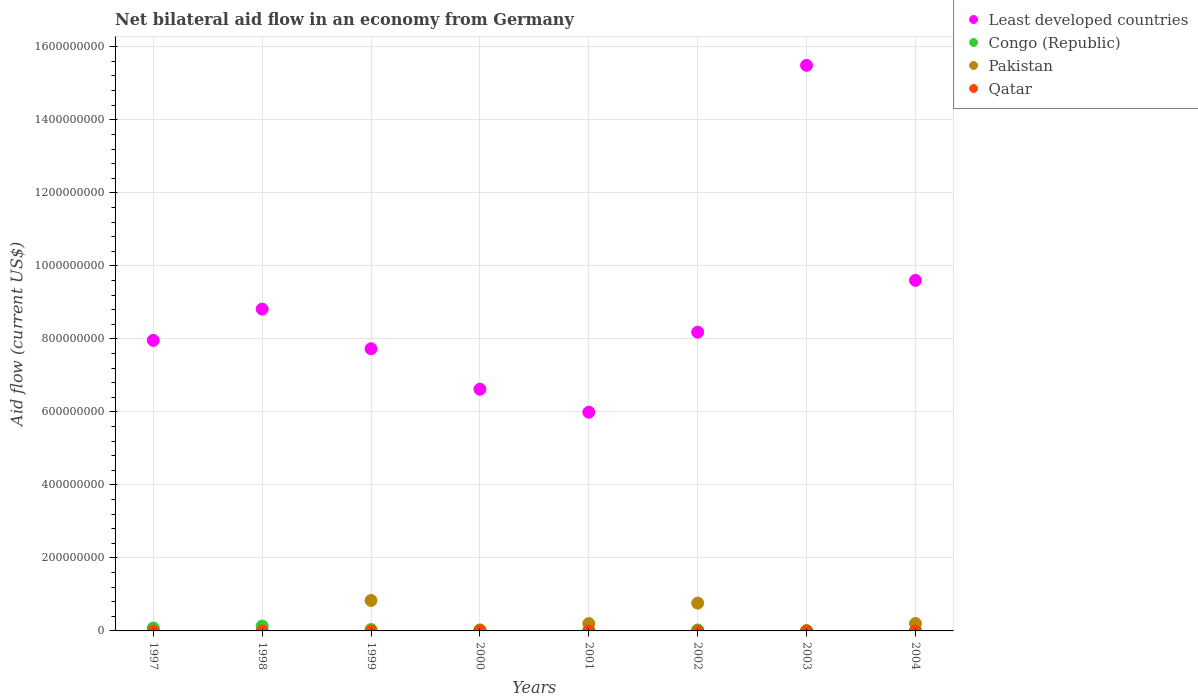How many different coloured dotlines are there?
Ensure brevity in your answer.  4. Across all years, what is the maximum net bilateral aid flow in Least developed countries?
Your answer should be very brief. 1.55e+09. Across all years, what is the minimum net bilateral aid flow in Congo (Republic)?
Offer a terse response. 5.20e+05. In which year was the net bilateral aid flow in Congo (Republic) maximum?
Keep it short and to the point. 1998. What is the total net bilateral aid flow in Congo (Republic) in the graph?
Ensure brevity in your answer.  3.32e+07. What is the difference between the net bilateral aid flow in Congo (Republic) in 2001 and that in 2003?
Ensure brevity in your answer.  8.10e+05. What is the difference between the net bilateral aid flow in Qatar in 2004 and the net bilateral aid flow in Least developed countries in 1997?
Your answer should be very brief. -7.96e+08. What is the average net bilateral aid flow in Qatar per year?
Your response must be concise. 9.12e+04. In the year 1998, what is the difference between the net bilateral aid flow in Congo (Republic) and net bilateral aid flow in Qatar?
Your answer should be very brief. 1.33e+07. What is the ratio of the net bilateral aid flow in Least developed countries in 1997 to that in 2002?
Offer a very short reply. 0.97. Is the net bilateral aid flow in Congo (Republic) in 2002 less than that in 2004?
Make the answer very short. No. What is the difference between the highest and the second highest net bilateral aid flow in Least developed countries?
Provide a short and direct response. 5.89e+08. What is the difference between the highest and the lowest net bilateral aid flow in Pakistan?
Provide a succinct answer. 8.34e+07. In how many years, is the net bilateral aid flow in Qatar greater than the average net bilateral aid flow in Qatar taken over all years?
Provide a succinct answer. 3. Is the sum of the net bilateral aid flow in Congo (Republic) in 1997 and 2000 greater than the maximum net bilateral aid flow in Pakistan across all years?
Provide a short and direct response. No. Is it the case that in every year, the sum of the net bilateral aid flow in Congo (Republic) and net bilateral aid flow in Pakistan  is greater than the net bilateral aid flow in Qatar?
Offer a terse response. Yes. Does the net bilateral aid flow in Congo (Republic) monotonically increase over the years?
Keep it short and to the point. No. Is the net bilateral aid flow in Congo (Republic) strictly less than the net bilateral aid flow in Qatar over the years?
Your answer should be compact. No. How many dotlines are there?
Give a very brief answer. 4. How many years are there in the graph?
Offer a very short reply. 8. What is the difference between two consecutive major ticks on the Y-axis?
Offer a very short reply. 2.00e+08. Does the graph contain grids?
Keep it short and to the point. Yes. How are the legend labels stacked?
Keep it short and to the point. Vertical. What is the title of the graph?
Your answer should be compact. Net bilateral aid flow in an economy from Germany. What is the label or title of the Y-axis?
Your answer should be compact. Aid flow (current US$). What is the Aid flow (current US$) of Least developed countries in 1997?
Make the answer very short. 7.96e+08. What is the Aid flow (current US$) of Congo (Republic) in 1997?
Ensure brevity in your answer.  7.95e+06. What is the Aid flow (current US$) in Least developed countries in 1998?
Keep it short and to the point. 8.81e+08. What is the Aid flow (current US$) of Congo (Republic) in 1998?
Keep it short and to the point. 1.35e+07. What is the Aid flow (current US$) of Pakistan in 1998?
Your answer should be very brief. 0. What is the Aid flow (current US$) of Qatar in 1998?
Your response must be concise. 1.40e+05. What is the Aid flow (current US$) of Least developed countries in 1999?
Your response must be concise. 7.73e+08. What is the Aid flow (current US$) of Congo (Republic) in 1999?
Provide a short and direct response. 3.76e+06. What is the Aid flow (current US$) in Pakistan in 1999?
Provide a succinct answer. 8.34e+07. What is the Aid flow (current US$) in Least developed countries in 2000?
Make the answer very short. 6.62e+08. What is the Aid flow (current US$) of Congo (Republic) in 2000?
Ensure brevity in your answer.  2.34e+06. What is the Aid flow (current US$) in Pakistan in 2000?
Your answer should be compact. 2.43e+06. What is the Aid flow (current US$) in Least developed countries in 2001?
Keep it short and to the point. 5.99e+08. What is the Aid flow (current US$) in Congo (Republic) in 2001?
Keep it short and to the point. 1.66e+06. What is the Aid flow (current US$) of Pakistan in 2001?
Your answer should be very brief. 2.01e+07. What is the Aid flow (current US$) of Least developed countries in 2002?
Your response must be concise. 8.18e+08. What is the Aid flow (current US$) of Congo (Republic) in 2002?
Offer a very short reply. 2.60e+06. What is the Aid flow (current US$) in Pakistan in 2002?
Keep it short and to the point. 7.62e+07. What is the Aid flow (current US$) in Qatar in 2002?
Provide a succinct answer. 8.00e+04. What is the Aid flow (current US$) of Least developed countries in 2003?
Make the answer very short. 1.55e+09. What is the Aid flow (current US$) in Congo (Republic) in 2003?
Your answer should be very brief. 8.50e+05. What is the Aid flow (current US$) of Least developed countries in 2004?
Provide a succinct answer. 9.60e+08. What is the Aid flow (current US$) of Congo (Republic) in 2004?
Provide a short and direct response. 5.20e+05. What is the Aid flow (current US$) of Pakistan in 2004?
Your answer should be compact. 2.04e+07. Across all years, what is the maximum Aid flow (current US$) in Least developed countries?
Offer a very short reply. 1.55e+09. Across all years, what is the maximum Aid flow (current US$) of Congo (Republic)?
Your answer should be compact. 1.35e+07. Across all years, what is the maximum Aid flow (current US$) of Pakistan?
Provide a succinct answer. 8.34e+07. Across all years, what is the minimum Aid flow (current US$) of Least developed countries?
Provide a short and direct response. 5.99e+08. Across all years, what is the minimum Aid flow (current US$) of Congo (Republic)?
Your answer should be compact. 5.20e+05. Across all years, what is the minimum Aid flow (current US$) in Pakistan?
Give a very brief answer. 0. Across all years, what is the minimum Aid flow (current US$) of Qatar?
Give a very brief answer. 5.00e+04. What is the total Aid flow (current US$) in Least developed countries in the graph?
Keep it short and to the point. 7.04e+09. What is the total Aid flow (current US$) in Congo (Republic) in the graph?
Your answer should be very brief. 3.32e+07. What is the total Aid flow (current US$) in Pakistan in the graph?
Your answer should be compact. 2.03e+08. What is the total Aid flow (current US$) in Qatar in the graph?
Your answer should be very brief. 7.30e+05. What is the difference between the Aid flow (current US$) in Least developed countries in 1997 and that in 1998?
Provide a short and direct response. -8.56e+07. What is the difference between the Aid flow (current US$) of Congo (Republic) in 1997 and that in 1998?
Give a very brief answer. -5.52e+06. What is the difference between the Aid flow (current US$) of Least developed countries in 1997 and that in 1999?
Your answer should be compact. 2.29e+07. What is the difference between the Aid flow (current US$) of Congo (Republic) in 1997 and that in 1999?
Give a very brief answer. 4.19e+06. What is the difference between the Aid flow (current US$) of Qatar in 1997 and that in 1999?
Offer a terse response. -6.00e+04. What is the difference between the Aid flow (current US$) of Least developed countries in 1997 and that in 2000?
Keep it short and to the point. 1.34e+08. What is the difference between the Aid flow (current US$) of Congo (Republic) in 1997 and that in 2000?
Ensure brevity in your answer.  5.61e+06. What is the difference between the Aid flow (current US$) in Least developed countries in 1997 and that in 2001?
Keep it short and to the point. 1.97e+08. What is the difference between the Aid flow (current US$) of Congo (Republic) in 1997 and that in 2001?
Your response must be concise. 6.29e+06. What is the difference between the Aid flow (current US$) of Qatar in 1997 and that in 2001?
Give a very brief answer. -3.00e+04. What is the difference between the Aid flow (current US$) in Least developed countries in 1997 and that in 2002?
Offer a very short reply. -2.25e+07. What is the difference between the Aid flow (current US$) in Congo (Republic) in 1997 and that in 2002?
Your answer should be compact. 5.35e+06. What is the difference between the Aid flow (current US$) of Qatar in 1997 and that in 2002?
Provide a succinct answer. -3.00e+04. What is the difference between the Aid flow (current US$) of Least developed countries in 1997 and that in 2003?
Your answer should be compact. -7.53e+08. What is the difference between the Aid flow (current US$) of Congo (Republic) in 1997 and that in 2003?
Offer a terse response. 7.10e+06. What is the difference between the Aid flow (current US$) in Qatar in 1997 and that in 2003?
Provide a succinct answer. -2.00e+04. What is the difference between the Aid flow (current US$) of Least developed countries in 1997 and that in 2004?
Keep it short and to the point. -1.64e+08. What is the difference between the Aid flow (current US$) of Congo (Republic) in 1997 and that in 2004?
Provide a short and direct response. 7.43e+06. What is the difference between the Aid flow (current US$) of Least developed countries in 1998 and that in 1999?
Your answer should be very brief. 1.09e+08. What is the difference between the Aid flow (current US$) in Congo (Republic) in 1998 and that in 1999?
Ensure brevity in your answer.  9.71e+06. What is the difference between the Aid flow (current US$) in Qatar in 1998 and that in 1999?
Offer a very short reply. 3.00e+04. What is the difference between the Aid flow (current US$) in Least developed countries in 1998 and that in 2000?
Provide a succinct answer. 2.19e+08. What is the difference between the Aid flow (current US$) of Congo (Republic) in 1998 and that in 2000?
Offer a terse response. 1.11e+07. What is the difference between the Aid flow (current US$) in Qatar in 1998 and that in 2000?
Offer a very short reply. 10000. What is the difference between the Aid flow (current US$) of Least developed countries in 1998 and that in 2001?
Provide a short and direct response. 2.82e+08. What is the difference between the Aid flow (current US$) in Congo (Republic) in 1998 and that in 2001?
Your answer should be compact. 1.18e+07. What is the difference between the Aid flow (current US$) in Least developed countries in 1998 and that in 2002?
Ensure brevity in your answer.  6.31e+07. What is the difference between the Aid flow (current US$) of Congo (Republic) in 1998 and that in 2002?
Provide a short and direct response. 1.09e+07. What is the difference between the Aid flow (current US$) in Qatar in 1998 and that in 2002?
Keep it short and to the point. 6.00e+04. What is the difference between the Aid flow (current US$) in Least developed countries in 1998 and that in 2003?
Give a very brief answer. -6.68e+08. What is the difference between the Aid flow (current US$) in Congo (Republic) in 1998 and that in 2003?
Your answer should be very brief. 1.26e+07. What is the difference between the Aid flow (current US$) in Least developed countries in 1998 and that in 2004?
Keep it short and to the point. -7.87e+07. What is the difference between the Aid flow (current US$) in Congo (Republic) in 1998 and that in 2004?
Your response must be concise. 1.30e+07. What is the difference between the Aid flow (current US$) of Qatar in 1998 and that in 2004?
Ensure brevity in your answer.  7.00e+04. What is the difference between the Aid flow (current US$) of Least developed countries in 1999 and that in 2000?
Your response must be concise. 1.11e+08. What is the difference between the Aid flow (current US$) in Congo (Republic) in 1999 and that in 2000?
Give a very brief answer. 1.42e+06. What is the difference between the Aid flow (current US$) of Pakistan in 1999 and that in 2000?
Ensure brevity in your answer.  8.10e+07. What is the difference between the Aid flow (current US$) of Qatar in 1999 and that in 2000?
Offer a terse response. -2.00e+04. What is the difference between the Aid flow (current US$) in Least developed countries in 1999 and that in 2001?
Offer a terse response. 1.74e+08. What is the difference between the Aid flow (current US$) in Congo (Republic) in 1999 and that in 2001?
Make the answer very short. 2.10e+06. What is the difference between the Aid flow (current US$) in Pakistan in 1999 and that in 2001?
Provide a short and direct response. 6.33e+07. What is the difference between the Aid flow (current US$) of Least developed countries in 1999 and that in 2002?
Give a very brief answer. -4.54e+07. What is the difference between the Aid flow (current US$) of Congo (Republic) in 1999 and that in 2002?
Your answer should be very brief. 1.16e+06. What is the difference between the Aid flow (current US$) in Pakistan in 1999 and that in 2002?
Provide a short and direct response. 7.25e+06. What is the difference between the Aid flow (current US$) of Least developed countries in 1999 and that in 2003?
Provide a short and direct response. -7.76e+08. What is the difference between the Aid flow (current US$) in Congo (Republic) in 1999 and that in 2003?
Ensure brevity in your answer.  2.91e+06. What is the difference between the Aid flow (current US$) of Qatar in 1999 and that in 2003?
Provide a succinct answer. 4.00e+04. What is the difference between the Aid flow (current US$) of Least developed countries in 1999 and that in 2004?
Your answer should be compact. -1.87e+08. What is the difference between the Aid flow (current US$) of Congo (Republic) in 1999 and that in 2004?
Provide a succinct answer. 3.24e+06. What is the difference between the Aid flow (current US$) in Pakistan in 1999 and that in 2004?
Your answer should be compact. 6.30e+07. What is the difference between the Aid flow (current US$) in Qatar in 1999 and that in 2004?
Give a very brief answer. 4.00e+04. What is the difference between the Aid flow (current US$) in Least developed countries in 2000 and that in 2001?
Provide a short and direct response. 6.29e+07. What is the difference between the Aid flow (current US$) of Congo (Republic) in 2000 and that in 2001?
Ensure brevity in your answer.  6.80e+05. What is the difference between the Aid flow (current US$) in Pakistan in 2000 and that in 2001?
Your answer should be very brief. -1.77e+07. What is the difference between the Aid flow (current US$) of Least developed countries in 2000 and that in 2002?
Your answer should be very brief. -1.56e+08. What is the difference between the Aid flow (current US$) of Pakistan in 2000 and that in 2002?
Provide a succinct answer. -7.38e+07. What is the difference between the Aid flow (current US$) of Least developed countries in 2000 and that in 2003?
Provide a short and direct response. -8.87e+08. What is the difference between the Aid flow (current US$) of Congo (Republic) in 2000 and that in 2003?
Offer a terse response. 1.49e+06. What is the difference between the Aid flow (current US$) in Qatar in 2000 and that in 2003?
Ensure brevity in your answer.  6.00e+04. What is the difference between the Aid flow (current US$) in Least developed countries in 2000 and that in 2004?
Make the answer very short. -2.98e+08. What is the difference between the Aid flow (current US$) of Congo (Republic) in 2000 and that in 2004?
Your response must be concise. 1.82e+06. What is the difference between the Aid flow (current US$) of Pakistan in 2000 and that in 2004?
Your answer should be compact. -1.80e+07. What is the difference between the Aid flow (current US$) in Qatar in 2000 and that in 2004?
Keep it short and to the point. 6.00e+04. What is the difference between the Aid flow (current US$) in Least developed countries in 2001 and that in 2002?
Offer a terse response. -2.19e+08. What is the difference between the Aid flow (current US$) in Congo (Republic) in 2001 and that in 2002?
Make the answer very short. -9.40e+05. What is the difference between the Aid flow (current US$) of Pakistan in 2001 and that in 2002?
Offer a very short reply. -5.61e+07. What is the difference between the Aid flow (current US$) in Least developed countries in 2001 and that in 2003?
Your response must be concise. -9.50e+08. What is the difference between the Aid flow (current US$) of Congo (Republic) in 2001 and that in 2003?
Ensure brevity in your answer.  8.10e+05. What is the difference between the Aid flow (current US$) of Least developed countries in 2001 and that in 2004?
Keep it short and to the point. -3.61e+08. What is the difference between the Aid flow (current US$) of Congo (Republic) in 2001 and that in 2004?
Give a very brief answer. 1.14e+06. What is the difference between the Aid flow (current US$) in Pakistan in 2001 and that in 2004?
Provide a succinct answer. -3.10e+05. What is the difference between the Aid flow (current US$) of Least developed countries in 2002 and that in 2003?
Your answer should be compact. -7.31e+08. What is the difference between the Aid flow (current US$) of Congo (Republic) in 2002 and that in 2003?
Give a very brief answer. 1.75e+06. What is the difference between the Aid flow (current US$) in Least developed countries in 2002 and that in 2004?
Keep it short and to the point. -1.42e+08. What is the difference between the Aid flow (current US$) in Congo (Republic) in 2002 and that in 2004?
Provide a succinct answer. 2.08e+06. What is the difference between the Aid flow (current US$) in Pakistan in 2002 and that in 2004?
Offer a very short reply. 5.58e+07. What is the difference between the Aid flow (current US$) of Qatar in 2002 and that in 2004?
Offer a terse response. 10000. What is the difference between the Aid flow (current US$) in Least developed countries in 2003 and that in 2004?
Your answer should be very brief. 5.89e+08. What is the difference between the Aid flow (current US$) of Least developed countries in 1997 and the Aid flow (current US$) of Congo (Republic) in 1998?
Your answer should be compact. 7.82e+08. What is the difference between the Aid flow (current US$) of Least developed countries in 1997 and the Aid flow (current US$) of Qatar in 1998?
Your answer should be compact. 7.96e+08. What is the difference between the Aid flow (current US$) in Congo (Republic) in 1997 and the Aid flow (current US$) in Qatar in 1998?
Make the answer very short. 7.81e+06. What is the difference between the Aid flow (current US$) in Least developed countries in 1997 and the Aid flow (current US$) in Congo (Republic) in 1999?
Provide a short and direct response. 7.92e+08. What is the difference between the Aid flow (current US$) in Least developed countries in 1997 and the Aid flow (current US$) in Pakistan in 1999?
Your answer should be very brief. 7.12e+08. What is the difference between the Aid flow (current US$) in Least developed countries in 1997 and the Aid flow (current US$) in Qatar in 1999?
Offer a very short reply. 7.96e+08. What is the difference between the Aid flow (current US$) of Congo (Republic) in 1997 and the Aid flow (current US$) of Pakistan in 1999?
Offer a very short reply. -7.55e+07. What is the difference between the Aid flow (current US$) of Congo (Republic) in 1997 and the Aid flow (current US$) of Qatar in 1999?
Your response must be concise. 7.84e+06. What is the difference between the Aid flow (current US$) in Least developed countries in 1997 and the Aid flow (current US$) in Congo (Republic) in 2000?
Offer a terse response. 7.94e+08. What is the difference between the Aid flow (current US$) in Least developed countries in 1997 and the Aid flow (current US$) in Pakistan in 2000?
Offer a terse response. 7.93e+08. What is the difference between the Aid flow (current US$) in Least developed countries in 1997 and the Aid flow (current US$) in Qatar in 2000?
Ensure brevity in your answer.  7.96e+08. What is the difference between the Aid flow (current US$) in Congo (Republic) in 1997 and the Aid flow (current US$) in Pakistan in 2000?
Provide a short and direct response. 5.52e+06. What is the difference between the Aid flow (current US$) in Congo (Republic) in 1997 and the Aid flow (current US$) in Qatar in 2000?
Provide a succinct answer. 7.82e+06. What is the difference between the Aid flow (current US$) of Least developed countries in 1997 and the Aid flow (current US$) of Congo (Republic) in 2001?
Offer a terse response. 7.94e+08. What is the difference between the Aid flow (current US$) of Least developed countries in 1997 and the Aid flow (current US$) of Pakistan in 2001?
Make the answer very short. 7.76e+08. What is the difference between the Aid flow (current US$) of Least developed countries in 1997 and the Aid flow (current US$) of Qatar in 2001?
Offer a terse response. 7.96e+08. What is the difference between the Aid flow (current US$) in Congo (Republic) in 1997 and the Aid flow (current US$) in Pakistan in 2001?
Make the answer very short. -1.22e+07. What is the difference between the Aid flow (current US$) in Congo (Republic) in 1997 and the Aid flow (current US$) in Qatar in 2001?
Your answer should be very brief. 7.87e+06. What is the difference between the Aid flow (current US$) in Least developed countries in 1997 and the Aid flow (current US$) in Congo (Republic) in 2002?
Keep it short and to the point. 7.93e+08. What is the difference between the Aid flow (current US$) in Least developed countries in 1997 and the Aid flow (current US$) in Pakistan in 2002?
Offer a very short reply. 7.20e+08. What is the difference between the Aid flow (current US$) of Least developed countries in 1997 and the Aid flow (current US$) of Qatar in 2002?
Your answer should be compact. 7.96e+08. What is the difference between the Aid flow (current US$) of Congo (Republic) in 1997 and the Aid flow (current US$) of Pakistan in 2002?
Your answer should be compact. -6.82e+07. What is the difference between the Aid flow (current US$) of Congo (Republic) in 1997 and the Aid flow (current US$) of Qatar in 2002?
Provide a short and direct response. 7.87e+06. What is the difference between the Aid flow (current US$) in Least developed countries in 1997 and the Aid flow (current US$) in Congo (Republic) in 2003?
Offer a terse response. 7.95e+08. What is the difference between the Aid flow (current US$) of Least developed countries in 1997 and the Aid flow (current US$) of Qatar in 2003?
Offer a very short reply. 7.96e+08. What is the difference between the Aid flow (current US$) of Congo (Republic) in 1997 and the Aid flow (current US$) of Qatar in 2003?
Your answer should be compact. 7.88e+06. What is the difference between the Aid flow (current US$) in Least developed countries in 1997 and the Aid flow (current US$) in Congo (Republic) in 2004?
Keep it short and to the point. 7.95e+08. What is the difference between the Aid flow (current US$) of Least developed countries in 1997 and the Aid flow (current US$) of Pakistan in 2004?
Your answer should be very brief. 7.75e+08. What is the difference between the Aid flow (current US$) in Least developed countries in 1997 and the Aid flow (current US$) in Qatar in 2004?
Your response must be concise. 7.96e+08. What is the difference between the Aid flow (current US$) of Congo (Republic) in 1997 and the Aid flow (current US$) of Pakistan in 2004?
Provide a succinct answer. -1.25e+07. What is the difference between the Aid flow (current US$) in Congo (Republic) in 1997 and the Aid flow (current US$) in Qatar in 2004?
Keep it short and to the point. 7.88e+06. What is the difference between the Aid flow (current US$) of Least developed countries in 1998 and the Aid flow (current US$) of Congo (Republic) in 1999?
Ensure brevity in your answer.  8.78e+08. What is the difference between the Aid flow (current US$) of Least developed countries in 1998 and the Aid flow (current US$) of Pakistan in 1999?
Provide a short and direct response. 7.98e+08. What is the difference between the Aid flow (current US$) of Least developed countries in 1998 and the Aid flow (current US$) of Qatar in 1999?
Offer a terse response. 8.81e+08. What is the difference between the Aid flow (current US$) in Congo (Republic) in 1998 and the Aid flow (current US$) in Pakistan in 1999?
Keep it short and to the point. -7.00e+07. What is the difference between the Aid flow (current US$) of Congo (Republic) in 1998 and the Aid flow (current US$) of Qatar in 1999?
Offer a terse response. 1.34e+07. What is the difference between the Aid flow (current US$) of Least developed countries in 1998 and the Aid flow (current US$) of Congo (Republic) in 2000?
Your answer should be compact. 8.79e+08. What is the difference between the Aid flow (current US$) in Least developed countries in 1998 and the Aid flow (current US$) in Pakistan in 2000?
Give a very brief answer. 8.79e+08. What is the difference between the Aid flow (current US$) of Least developed countries in 1998 and the Aid flow (current US$) of Qatar in 2000?
Offer a terse response. 8.81e+08. What is the difference between the Aid flow (current US$) in Congo (Republic) in 1998 and the Aid flow (current US$) in Pakistan in 2000?
Give a very brief answer. 1.10e+07. What is the difference between the Aid flow (current US$) of Congo (Republic) in 1998 and the Aid flow (current US$) of Qatar in 2000?
Your answer should be compact. 1.33e+07. What is the difference between the Aid flow (current US$) in Least developed countries in 1998 and the Aid flow (current US$) in Congo (Republic) in 2001?
Keep it short and to the point. 8.80e+08. What is the difference between the Aid flow (current US$) of Least developed countries in 1998 and the Aid flow (current US$) of Pakistan in 2001?
Your answer should be compact. 8.61e+08. What is the difference between the Aid flow (current US$) in Least developed countries in 1998 and the Aid flow (current US$) in Qatar in 2001?
Offer a very short reply. 8.81e+08. What is the difference between the Aid flow (current US$) in Congo (Republic) in 1998 and the Aid flow (current US$) in Pakistan in 2001?
Provide a short and direct response. -6.63e+06. What is the difference between the Aid flow (current US$) in Congo (Republic) in 1998 and the Aid flow (current US$) in Qatar in 2001?
Make the answer very short. 1.34e+07. What is the difference between the Aid flow (current US$) in Least developed countries in 1998 and the Aid flow (current US$) in Congo (Republic) in 2002?
Your response must be concise. 8.79e+08. What is the difference between the Aid flow (current US$) of Least developed countries in 1998 and the Aid flow (current US$) of Pakistan in 2002?
Ensure brevity in your answer.  8.05e+08. What is the difference between the Aid flow (current US$) in Least developed countries in 1998 and the Aid flow (current US$) in Qatar in 2002?
Offer a terse response. 8.81e+08. What is the difference between the Aid flow (current US$) in Congo (Republic) in 1998 and the Aid flow (current US$) in Pakistan in 2002?
Your response must be concise. -6.27e+07. What is the difference between the Aid flow (current US$) in Congo (Republic) in 1998 and the Aid flow (current US$) in Qatar in 2002?
Provide a succinct answer. 1.34e+07. What is the difference between the Aid flow (current US$) in Least developed countries in 1998 and the Aid flow (current US$) in Congo (Republic) in 2003?
Provide a succinct answer. 8.81e+08. What is the difference between the Aid flow (current US$) in Least developed countries in 1998 and the Aid flow (current US$) in Qatar in 2003?
Your answer should be compact. 8.81e+08. What is the difference between the Aid flow (current US$) in Congo (Republic) in 1998 and the Aid flow (current US$) in Qatar in 2003?
Your answer should be very brief. 1.34e+07. What is the difference between the Aid flow (current US$) in Least developed countries in 1998 and the Aid flow (current US$) in Congo (Republic) in 2004?
Give a very brief answer. 8.81e+08. What is the difference between the Aid flow (current US$) in Least developed countries in 1998 and the Aid flow (current US$) in Pakistan in 2004?
Offer a terse response. 8.61e+08. What is the difference between the Aid flow (current US$) of Least developed countries in 1998 and the Aid flow (current US$) of Qatar in 2004?
Offer a terse response. 8.81e+08. What is the difference between the Aid flow (current US$) of Congo (Republic) in 1998 and the Aid flow (current US$) of Pakistan in 2004?
Offer a terse response. -6.94e+06. What is the difference between the Aid flow (current US$) in Congo (Republic) in 1998 and the Aid flow (current US$) in Qatar in 2004?
Offer a very short reply. 1.34e+07. What is the difference between the Aid flow (current US$) of Least developed countries in 1999 and the Aid flow (current US$) of Congo (Republic) in 2000?
Your response must be concise. 7.71e+08. What is the difference between the Aid flow (current US$) in Least developed countries in 1999 and the Aid flow (current US$) in Pakistan in 2000?
Your answer should be very brief. 7.70e+08. What is the difference between the Aid flow (current US$) in Least developed countries in 1999 and the Aid flow (current US$) in Qatar in 2000?
Give a very brief answer. 7.73e+08. What is the difference between the Aid flow (current US$) of Congo (Republic) in 1999 and the Aid flow (current US$) of Pakistan in 2000?
Give a very brief answer. 1.33e+06. What is the difference between the Aid flow (current US$) of Congo (Republic) in 1999 and the Aid flow (current US$) of Qatar in 2000?
Keep it short and to the point. 3.63e+06. What is the difference between the Aid flow (current US$) in Pakistan in 1999 and the Aid flow (current US$) in Qatar in 2000?
Provide a succinct answer. 8.33e+07. What is the difference between the Aid flow (current US$) in Least developed countries in 1999 and the Aid flow (current US$) in Congo (Republic) in 2001?
Offer a very short reply. 7.71e+08. What is the difference between the Aid flow (current US$) of Least developed countries in 1999 and the Aid flow (current US$) of Pakistan in 2001?
Your answer should be compact. 7.53e+08. What is the difference between the Aid flow (current US$) in Least developed countries in 1999 and the Aid flow (current US$) in Qatar in 2001?
Your answer should be very brief. 7.73e+08. What is the difference between the Aid flow (current US$) of Congo (Republic) in 1999 and the Aid flow (current US$) of Pakistan in 2001?
Make the answer very short. -1.63e+07. What is the difference between the Aid flow (current US$) in Congo (Republic) in 1999 and the Aid flow (current US$) in Qatar in 2001?
Offer a very short reply. 3.68e+06. What is the difference between the Aid flow (current US$) in Pakistan in 1999 and the Aid flow (current US$) in Qatar in 2001?
Provide a succinct answer. 8.34e+07. What is the difference between the Aid flow (current US$) in Least developed countries in 1999 and the Aid flow (current US$) in Congo (Republic) in 2002?
Provide a short and direct response. 7.70e+08. What is the difference between the Aid flow (current US$) in Least developed countries in 1999 and the Aid flow (current US$) in Pakistan in 2002?
Provide a short and direct response. 6.97e+08. What is the difference between the Aid flow (current US$) of Least developed countries in 1999 and the Aid flow (current US$) of Qatar in 2002?
Offer a terse response. 7.73e+08. What is the difference between the Aid flow (current US$) of Congo (Republic) in 1999 and the Aid flow (current US$) of Pakistan in 2002?
Your answer should be very brief. -7.24e+07. What is the difference between the Aid flow (current US$) of Congo (Republic) in 1999 and the Aid flow (current US$) of Qatar in 2002?
Provide a succinct answer. 3.68e+06. What is the difference between the Aid flow (current US$) in Pakistan in 1999 and the Aid flow (current US$) in Qatar in 2002?
Ensure brevity in your answer.  8.34e+07. What is the difference between the Aid flow (current US$) in Least developed countries in 1999 and the Aid flow (current US$) in Congo (Republic) in 2003?
Give a very brief answer. 7.72e+08. What is the difference between the Aid flow (current US$) of Least developed countries in 1999 and the Aid flow (current US$) of Qatar in 2003?
Your answer should be compact. 7.73e+08. What is the difference between the Aid flow (current US$) in Congo (Republic) in 1999 and the Aid flow (current US$) in Qatar in 2003?
Make the answer very short. 3.69e+06. What is the difference between the Aid flow (current US$) in Pakistan in 1999 and the Aid flow (current US$) in Qatar in 2003?
Make the answer very short. 8.34e+07. What is the difference between the Aid flow (current US$) of Least developed countries in 1999 and the Aid flow (current US$) of Congo (Republic) in 2004?
Provide a succinct answer. 7.72e+08. What is the difference between the Aid flow (current US$) of Least developed countries in 1999 and the Aid flow (current US$) of Pakistan in 2004?
Offer a terse response. 7.53e+08. What is the difference between the Aid flow (current US$) of Least developed countries in 1999 and the Aid flow (current US$) of Qatar in 2004?
Give a very brief answer. 7.73e+08. What is the difference between the Aid flow (current US$) of Congo (Republic) in 1999 and the Aid flow (current US$) of Pakistan in 2004?
Ensure brevity in your answer.  -1.66e+07. What is the difference between the Aid flow (current US$) in Congo (Republic) in 1999 and the Aid flow (current US$) in Qatar in 2004?
Provide a short and direct response. 3.69e+06. What is the difference between the Aid flow (current US$) in Pakistan in 1999 and the Aid flow (current US$) in Qatar in 2004?
Your answer should be very brief. 8.34e+07. What is the difference between the Aid flow (current US$) of Least developed countries in 2000 and the Aid flow (current US$) of Congo (Republic) in 2001?
Make the answer very short. 6.60e+08. What is the difference between the Aid flow (current US$) of Least developed countries in 2000 and the Aid flow (current US$) of Pakistan in 2001?
Your response must be concise. 6.42e+08. What is the difference between the Aid flow (current US$) of Least developed countries in 2000 and the Aid flow (current US$) of Qatar in 2001?
Your response must be concise. 6.62e+08. What is the difference between the Aid flow (current US$) in Congo (Republic) in 2000 and the Aid flow (current US$) in Pakistan in 2001?
Provide a succinct answer. -1.78e+07. What is the difference between the Aid flow (current US$) in Congo (Republic) in 2000 and the Aid flow (current US$) in Qatar in 2001?
Provide a succinct answer. 2.26e+06. What is the difference between the Aid flow (current US$) of Pakistan in 2000 and the Aid flow (current US$) of Qatar in 2001?
Your answer should be very brief. 2.35e+06. What is the difference between the Aid flow (current US$) in Least developed countries in 2000 and the Aid flow (current US$) in Congo (Republic) in 2002?
Provide a succinct answer. 6.59e+08. What is the difference between the Aid flow (current US$) of Least developed countries in 2000 and the Aid flow (current US$) of Pakistan in 2002?
Your answer should be very brief. 5.86e+08. What is the difference between the Aid flow (current US$) of Least developed countries in 2000 and the Aid flow (current US$) of Qatar in 2002?
Make the answer very short. 6.62e+08. What is the difference between the Aid flow (current US$) of Congo (Republic) in 2000 and the Aid flow (current US$) of Pakistan in 2002?
Keep it short and to the point. -7.38e+07. What is the difference between the Aid flow (current US$) of Congo (Republic) in 2000 and the Aid flow (current US$) of Qatar in 2002?
Make the answer very short. 2.26e+06. What is the difference between the Aid flow (current US$) of Pakistan in 2000 and the Aid flow (current US$) of Qatar in 2002?
Offer a very short reply. 2.35e+06. What is the difference between the Aid flow (current US$) of Least developed countries in 2000 and the Aid flow (current US$) of Congo (Republic) in 2003?
Offer a terse response. 6.61e+08. What is the difference between the Aid flow (current US$) in Least developed countries in 2000 and the Aid flow (current US$) in Qatar in 2003?
Provide a short and direct response. 6.62e+08. What is the difference between the Aid flow (current US$) of Congo (Republic) in 2000 and the Aid flow (current US$) of Qatar in 2003?
Keep it short and to the point. 2.27e+06. What is the difference between the Aid flow (current US$) in Pakistan in 2000 and the Aid flow (current US$) in Qatar in 2003?
Your answer should be compact. 2.36e+06. What is the difference between the Aid flow (current US$) in Least developed countries in 2000 and the Aid flow (current US$) in Congo (Republic) in 2004?
Your answer should be very brief. 6.61e+08. What is the difference between the Aid flow (current US$) in Least developed countries in 2000 and the Aid flow (current US$) in Pakistan in 2004?
Make the answer very short. 6.42e+08. What is the difference between the Aid flow (current US$) of Least developed countries in 2000 and the Aid flow (current US$) of Qatar in 2004?
Make the answer very short. 6.62e+08. What is the difference between the Aid flow (current US$) of Congo (Republic) in 2000 and the Aid flow (current US$) of Pakistan in 2004?
Offer a terse response. -1.81e+07. What is the difference between the Aid flow (current US$) of Congo (Republic) in 2000 and the Aid flow (current US$) of Qatar in 2004?
Keep it short and to the point. 2.27e+06. What is the difference between the Aid flow (current US$) in Pakistan in 2000 and the Aid flow (current US$) in Qatar in 2004?
Your answer should be compact. 2.36e+06. What is the difference between the Aid flow (current US$) in Least developed countries in 2001 and the Aid flow (current US$) in Congo (Republic) in 2002?
Provide a short and direct response. 5.96e+08. What is the difference between the Aid flow (current US$) in Least developed countries in 2001 and the Aid flow (current US$) in Pakistan in 2002?
Your answer should be compact. 5.23e+08. What is the difference between the Aid flow (current US$) in Least developed countries in 2001 and the Aid flow (current US$) in Qatar in 2002?
Ensure brevity in your answer.  5.99e+08. What is the difference between the Aid flow (current US$) of Congo (Republic) in 2001 and the Aid flow (current US$) of Pakistan in 2002?
Your answer should be very brief. -7.45e+07. What is the difference between the Aid flow (current US$) in Congo (Republic) in 2001 and the Aid flow (current US$) in Qatar in 2002?
Give a very brief answer. 1.58e+06. What is the difference between the Aid flow (current US$) of Pakistan in 2001 and the Aid flow (current US$) of Qatar in 2002?
Keep it short and to the point. 2.00e+07. What is the difference between the Aid flow (current US$) in Least developed countries in 2001 and the Aid flow (current US$) in Congo (Republic) in 2003?
Offer a terse response. 5.98e+08. What is the difference between the Aid flow (current US$) of Least developed countries in 2001 and the Aid flow (current US$) of Qatar in 2003?
Your answer should be compact. 5.99e+08. What is the difference between the Aid flow (current US$) in Congo (Republic) in 2001 and the Aid flow (current US$) in Qatar in 2003?
Provide a succinct answer. 1.59e+06. What is the difference between the Aid flow (current US$) of Pakistan in 2001 and the Aid flow (current US$) of Qatar in 2003?
Provide a short and direct response. 2.00e+07. What is the difference between the Aid flow (current US$) of Least developed countries in 2001 and the Aid flow (current US$) of Congo (Republic) in 2004?
Your answer should be compact. 5.99e+08. What is the difference between the Aid flow (current US$) in Least developed countries in 2001 and the Aid flow (current US$) in Pakistan in 2004?
Your answer should be compact. 5.79e+08. What is the difference between the Aid flow (current US$) in Least developed countries in 2001 and the Aid flow (current US$) in Qatar in 2004?
Give a very brief answer. 5.99e+08. What is the difference between the Aid flow (current US$) of Congo (Republic) in 2001 and the Aid flow (current US$) of Pakistan in 2004?
Offer a very short reply. -1.88e+07. What is the difference between the Aid flow (current US$) in Congo (Republic) in 2001 and the Aid flow (current US$) in Qatar in 2004?
Your answer should be compact. 1.59e+06. What is the difference between the Aid flow (current US$) in Pakistan in 2001 and the Aid flow (current US$) in Qatar in 2004?
Make the answer very short. 2.00e+07. What is the difference between the Aid flow (current US$) of Least developed countries in 2002 and the Aid flow (current US$) of Congo (Republic) in 2003?
Make the answer very short. 8.17e+08. What is the difference between the Aid flow (current US$) in Least developed countries in 2002 and the Aid flow (current US$) in Qatar in 2003?
Make the answer very short. 8.18e+08. What is the difference between the Aid flow (current US$) of Congo (Republic) in 2002 and the Aid flow (current US$) of Qatar in 2003?
Offer a very short reply. 2.53e+06. What is the difference between the Aid flow (current US$) in Pakistan in 2002 and the Aid flow (current US$) in Qatar in 2003?
Your answer should be very brief. 7.61e+07. What is the difference between the Aid flow (current US$) in Least developed countries in 2002 and the Aid flow (current US$) in Congo (Republic) in 2004?
Your answer should be very brief. 8.18e+08. What is the difference between the Aid flow (current US$) in Least developed countries in 2002 and the Aid flow (current US$) in Pakistan in 2004?
Provide a short and direct response. 7.98e+08. What is the difference between the Aid flow (current US$) in Least developed countries in 2002 and the Aid flow (current US$) in Qatar in 2004?
Provide a succinct answer. 8.18e+08. What is the difference between the Aid flow (current US$) in Congo (Republic) in 2002 and the Aid flow (current US$) in Pakistan in 2004?
Provide a succinct answer. -1.78e+07. What is the difference between the Aid flow (current US$) in Congo (Republic) in 2002 and the Aid flow (current US$) in Qatar in 2004?
Offer a very short reply. 2.53e+06. What is the difference between the Aid flow (current US$) of Pakistan in 2002 and the Aid flow (current US$) of Qatar in 2004?
Your answer should be compact. 7.61e+07. What is the difference between the Aid flow (current US$) of Least developed countries in 2003 and the Aid flow (current US$) of Congo (Republic) in 2004?
Offer a terse response. 1.55e+09. What is the difference between the Aid flow (current US$) of Least developed countries in 2003 and the Aid flow (current US$) of Pakistan in 2004?
Keep it short and to the point. 1.53e+09. What is the difference between the Aid flow (current US$) of Least developed countries in 2003 and the Aid flow (current US$) of Qatar in 2004?
Offer a very short reply. 1.55e+09. What is the difference between the Aid flow (current US$) in Congo (Republic) in 2003 and the Aid flow (current US$) in Pakistan in 2004?
Make the answer very short. -1.96e+07. What is the difference between the Aid flow (current US$) in Congo (Republic) in 2003 and the Aid flow (current US$) in Qatar in 2004?
Ensure brevity in your answer.  7.80e+05. What is the average Aid flow (current US$) in Least developed countries per year?
Keep it short and to the point. 8.80e+08. What is the average Aid flow (current US$) of Congo (Republic) per year?
Your answer should be compact. 4.14e+06. What is the average Aid flow (current US$) of Pakistan per year?
Your response must be concise. 2.53e+07. What is the average Aid flow (current US$) of Qatar per year?
Your response must be concise. 9.12e+04. In the year 1997, what is the difference between the Aid flow (current US$) of Least developed countries and Aid flow (current US$) of Congo (Republic)?
Provide a succinct answer. 7.88e+08. In the year 1997, what is the difference between the Aid flow (current US$) in Least developed countries and Aid flow (current US$) in Qatar?
Make the answer very short. 7.96e+08. In the year 1997, what is the difference between the Aid flow (current US$) in Congo (Republic) and Aid flow (current US$) in Qatar?
Make the answer very short. 7.90e+06. In the year 1998, what is the difference between the Aid flow (current US$) of Least developed countries and Aid flow (current US$) of Congo (Republic)?
Keep it short and to the point. 8.68e+08. In the year 1998, what is the difference between the Aid flow (current US$) of Least developed countries and Aid flow (current US$) of Qatar?
Provide a succinct answer. 8.81e+08. In the year 1998, what is the difference between the Aid flow (current US$) in Congo (Republic) and Aid flow (current US$) in Qatar?
Your answer should be very brief. 1.33e+07. In the year 1999, what is the difference between the Aid flow (current US$) of Least developed countries and Aid flow (current US$) of Congo (Republic)?
Keep it short and to the point. 7.69e+08. In the year 1999, what is the difference between the Aid flow (current US$) of Least developed countries and Aid flow (current US$) of Pakistan?
Give a very brief answer. 6.89e+08. In the year 1999, what is the difference between the Aid flow (current US$) of Least developed countries and Aid flow (current US$) of Qatar?
Make the answer very short. 7.73e+08. In the year 1999, what is the difference between the Aid flow (current US$) in Congo (Republic) and Aid flow (current US$) in Pakistan?
Give a very brief answer. -7.97e+07. In the year 1999, what is the difference between the Aid flow (current US$) in Congo (Republic) and Aid flow (current US$) in Qatar?
Keep it short and to the point. 3.65e+06. In the year 1999, what is the difference between the Aid flow (current US$) of Pakistan and Aid flow (current US$) of Qatar?
Your answer should be compact. 8.33e+07. In the year 2000, what is the difference between the Aid flow (current US$) of Least developed countries and Aid flow (current US$) of Congo (Republic)?
Your answer should be very brief. 6.60e+08. In the year 2000, what is the difference between the Aid flow (current US$) of Least developed countries and Aid flow (current US$) of Pakistan?
Offer a terse response. 6.60e+08. In the year 2000, what is the difference between the Aid flow (current US$) of Least developed countries and Aid flow (current US$) of Qatar?
Your response must be concise. 6.62e+08. In the year 2000, what is the difference between the Aid flow (current US$) in Congo (Republic) and Aid flow (current US$) in Pakistan?
Your answer should be very brief. -9.00e+04. In the year 2000, what is the difference between the Aid flow (current US$) in Congo (Republic) and Aid flow (current US$) in Qatar?
Give a very brief answer. 2.21e+06. In the year 2000, what is the difference between the Aid flow (current US$) in Pakistan and Aid flow (current US$) in Qatar?
Make the answer very short. 2.30e+06. In the year 2001, what is the difference between the Aid flow (current US$) of Least developed countries and Aid flow (current US$) of Congo (Republic)?
Offer a terse response. 5.97e+08. In the year 2001, what is the difference between the Aid flow (current US$) in Least developed countries and Aid flow (current US$) in Pakistan?
Offer a very short reply. 5.79e+08. In the year 2001, what is the difference between the Aid flow (current US$) of Least developed countries and Aid flow (current US$) of Qatar?
Offer a very short reply. 5.99e+08. In the year 2001, what is the difference between the Aid flow (current US$) of Congo (Republic) and Aid flow (current US$) of Pakistan?
Keep it short and to the point. -1.84e+07. In the year 2001, what is the difference between the Aid flow (current US$) in Congo (Republic) and Aid flow (current US$) in Qatar?
Give a very brief answer. 1.58e+06. In the year 2001, what is the difference between the Aid flow (current US$) in Pakistan and Aid flow (current US$) in Qatar?
Make the answer very short. 2.00e+07. In the year 2002, what is the difference between the Aid flow (current US$) in Least developed countries and Aid flow (current US$) in Congo (Republic)?
Offer a very short reply. 8.16e+08. In the year 2002, what is the difference between the Aid flow (current US$) of Least developed countries and Aid flow (current US$) of Pakistan?
Give a very brief answer. 7.42e+08. In the year 2002, what is the difference between the Aid flow (current US$) of Least developed countries and Aid flow (current US$) of Qatar?
Provide a succinct answer. 8.18e+08. In the year 2002, what is the difference between the Aid flow (current US$) of Congo (Republic) and Aid flow (current US$) of Pakistan?
Your answer should be very brief. -7.36e+07. In the year 2002, what is the difference between the Aid flow (current US$) in Congo (Republic) and Aid flow (current US$) in Qatar?
Provide a short and direct response. 2.52e+06. In the year 2002, what is the difference between the Aid flow (current US$) of Pakistan and Aid flow (current US$) of Qatar?
Provide a short and direct response. 7.61e+07. In the year 2003, what is the difference between the Aid flow (current US$) of Least developed countries and Aid flow (current US$) of Congo (Republic)?
Provide a succinct answer. 1.55e+09. In the year 2003, what is the difference between the Aid flow (current US$) in Least developed countries and Aid flow (current US$) in Qatar?
Make the answer very short. 1.55e+09. In the year 2003, what is the difference between the Aid flow (current US$) in Congo (Republic) and Aid flow (current US$) in Qatar?
Your response must be concise. 7.80e+05. In the year 2004, what is the difference between the Aid flow (current US$) in Least developed countries and Aid flow (current US$) in Congo (Republic)?
Provide a short and direct response. 9.60e+08. In the year 2004, what is the difference between the Aid flow (current US$) in Least developed countries and Aid flow (current US$) in Pakistan?
Provide a short and direct response. 9.40e+08. In the year 2004, what is the difference between the Aid flow (current US$) of Least developed countries and Aid flow (current US$) of Qatar?
Offer a terse response. 9.60e+08. In the year 2004, what is the difference between the Aid flow (current US$) in Congo (Republic) and Aid flow (current US$) in Pakistan?
Give a very brief answer. -1.99e+07. In the year 2004, what is the difference between the Aid flow (current US$) in Congo (Republic) and Aid flow (current US$) in Qatar?
Offer a very short reply. 4.50e+05. In the year 2004, what is the difference between the Aid flow (current US$) in Pakistan and Aid flow (current US$) in Qatar?
Your answer should be compact. 2.03e+07. What is the ratio of the Aid flow (current US$) in Least developed countries in 1997 to that in 1998?
Offer a very short reply. 0.9. What is the ratio of the Aid flow (current US$) of Congo (Republic) in 1997 to that in 1998?
Give a very brief answer. 0.59. What is the ratio of the Aid flow (current US$) of Qatar in 1997 to that in 1998?
Offer a very short reply. 0.36. What is the ratio of the Aid flow (current US$) of Least developed countries in 1997 to that in 1999?
Make the answer very short. 1.03. What is the ratio of the Aid flow (current US$) in Congo (Republic) in 1997 to that in 1999?
Keep it short and to the point. 2.11. What is the ratio of the Aid flow (current US$) in Qatar in 1997 to that in 1999?
Ensure brevity in your answer.  0.45. What is the ratio of the Aid flow (current US$) of Least developed countries in 1997 to that in 2000?
Make the answer very short. 1.2. What is the ratio of the Aid flow (current US$) of Congo (Republic) in 1997 to that in 2000?
Offer a terse response. 3.4. What is the ratio of the Aid flow (current US$) in Qatar in 1997 to that in 2000?
Offer a terse response. 0.38. What is the ratio of the Aid flow (current US$) in Least developed countries in 1997 to that in 2001?
Make the answer very short. 1.33. What is the ratio of the Aid flow (current US$) in Congo (Republic) in 1997 to that in 2001?
Offer a terse response. 4.79. What is the ratio of the Aid flow (current US$) of Qatar in 1997 to that in 2001?
Offer a terse response. 0.62. What is the ratio of the Aid flow (current US$) of Least developed countries in 1997 to that in 2002?
Offer a terse response. 0.97. What is the ratio of the Aid flow (current US$) of Congo (Republic) in 1997 to that in 2002?
Your answer should be very brief. 3.06. What is the ratio of the Aid flow (current US$) in Least developed countries in 1997 to that in 2003?
Provide a succinct answer. 0.51. What is the ratio of the Aid flow (current US$) in Congo (Republic) in 1997 to that in 2003?
Keep it short and to the point. 9.35. What is the ratio of the Aid flow (current US$) in Least developed countries in 1997 to that in 2004?
Offer a very short reply. 0.83. What is the ratio of the Aid flow (current US$) of Congo (Republic) in 1997 to that in 2004?
Give a very brief answer. 15.29. What is the ratio of the Aid flow (current US$) of Least developed countries in 1998 to that in 1999?
Make the answer very short. 1.14. What is the ratio of the Aid flow (current US$) of Congo (Republic) in 1998 to that in 1999?
Your answer should be very brief. 3.58. What is the ratio of the Aid flow (current US$) of Qatar in 1998 to that in 1999?
Offer a terse response. 1.27. What is the ratio of the Aid flow (current US$) in Least developed countries in 1998 to that in 2000?
Offer a terse response. 1.33. What is the ratio of the Aid flow (current US$) in Congo (Republic) in 1998 to that in 2000?
Keep it short and to the point. 5.76. What is the ratio of the Aid flow (current US$) of Least developed countries in 1998 to that in 2001?
Your response must be concise. 1.47. What is the ratio of the Aid flow (current US$) in Congo (Republic) in 1998 to that in 2001?
Your response must be concise. 8.11. What is the ratio of the Aid flow (current US$) in Least developed countries in 1998 to that in 2002?
Keep it short and to the point. 1.08. What is the ratio of the Aid flow (current US$) of Congo (Republic) in 1998 to that in 2002?
Keep it short and to the point. 5.18. What is the ratio of the Aid flow (current US$) in Least developed countries in 1998 to that in 2003?
Offer a very short reply. 0.57. What is the ratio of the Aid flow (current US$) in Congo (Republic) in 1998 to that in 2003?
Offer a very short reply. 15.85. What is the ratio of the Aid flow (current US$) in Qatar in 1998 to that in 2003?
Keep it short and to the point. 2. What is the ratio of the Aid flow (current US$) of Least developed countries in 1998 to that in 2004?
Provide a succinct answer. 0.92. What is the ratio of the Aid flow (current US$) of Congo (Republic) in 1998 to that in 2004?
Provide a short and direct response. 25.9. What is the ratio of the Aid flow (current US$) in Qatar in 1998 to that in 2004?
Provide a short and direct response. 2. What is the ratio of the Aid flow (current US$) in Least developed countries in 1999 to that in 2000?
Keep it short and to the point. 1.17. What is the ratio of the Aid flow (current US$) in Congo (Republic) in 1999 to that in 2000?
Keep it short and to the point. 1.61. What is the ratio of the Aid flow (current US$) in Pakistan in 1999 to that in 2000?
Offer a terse response. 34.33. What is the ratio of the Aid flow (current US$) in Qatar in 1999 to that in 2000?
Your answer should be very brief. 0.85. What is the ratio of the Aid flow (current US$) of Least developed countries in 1999 to that in 2001?
Make the answer very short. 1.29. What is the ratio of the Aid flow (current US$) of Congo (Republic) in 1999 to that in 2001?
Offer a terse response. 2.27. What is the ratio of the Aid flow (current US$) of Pakistan in 1999 to that in 2001?
Your answer should be compact. 4.15. What is the ratio of the Aid flow (current US$) in Qatar in 1999 to that in 2001?
Your response must be concise. 1.38. What is the ratio of the Aid flow (current US$) in Least developed countries in 1999 to that in 2002?
Provide a succinct answer. 0.94. What is the ratio of the Aid flow (current US$) in Congo (Republic) in 1999 to that in 2002?
Your answer should be compact. 1.45. What is the ratio of the Aid flow (current US$) of Pakistan in 1999 to that in 2002?
Provide a short and direct response. 1.1. What is the ratio of the Aid flow (current US$) in Qatar in 1999 to that in 2002?
Give a very brief answer. 1.38. What is the ratio of the Aid flow (current US$) of Least developed countries in 1999 to that in 2003?
Offer a terse response. 0.5. What is the ratio of the Aid flow (current US$) in Congo (Republic) in 1999 to that in 2003?
Offer a very short reply. 4.42. What is the ratio of the Aid flow (current US$) in Qatar in 1999 to that in 2003?
Your response must be concise. 1.57. What is the ratio of the Aid flow (current US$) in Least developed countries in 1999 to that in 2004?
Make the answer very short. 0.81. What is the ratio of the Aid flow (current US$) in Congo (Republic) in 1999 to that in 2004?
Provide a short and direct response. 7.23. What is the ratio of the Aid flow (current US$) of Pakistan in 1999 to that in 2004?
Provide a short and direct response. 4.09. What is the ratio of the Aid flow (current US$) in Qatar in 1999 to that in 2004?
Your answer should be compact. 1.57. What is the ratio of the Aid flow (current US$) in Least developed countries in 2000 to that in 2001?
Your answer should be very brief. 1.1. What is the ratio of the Aid flow (current US$) of Congo (Republic) in 2000 to that in 2001?
Your response must be concise. 1.41. What is the ratio of the Aid flow (current US$) in Pakistan in 2000 to that in 2001?
Keep it short and to the point. 0.12. What is the ratio of the Aid flow (current US$) of Qatar in 2000 to that in 2001?
Ensure brevity in your answer.  1.62. What is the ratio of the Aid flow (current US$) of Least developed countries in 2000 to that in 2002?
Offer a terse response. 0.81. What is the ratio of the Aid flow (current US$) in Congo (Republic) in 2000 to that in 2002?
Offer a terse response. 0.9. What is the ratio of the Aid flow (current US$) of Pakistan in 2000 to that in 2002?
Provide a short and direct response. 0.03. What is the ratio of the Aid flow (current US$) of Qatar in 2000 to that in 2002?
Ensure brevity in your answer.  1.62. What is the ratio of the Aid flow (current US$) of Least developed countries in 2000 to that in 2003?
Your answer should be very brief. 0.43. What is the ratio of the Aid flow (current US$) of Congo (Republic) in 2000 to that in 2003?
Provide a short and direct response. 2.75. What is the ratio of the Aid flow (current US$) in Qatar in 2000 to that in 2003?
Provide a succinct answer. 1.86. What is the ratio of the Aid flow (current US$) of Least developed countries in 2000 to that in 2004?
Provide a short and direct response. 0.69. What is the ratio of the Aid flow (current US$) of Pakistan in 2000 to that in 2004?
Offer a very short reply. 0.12. What is the ratio of the Aid flow (current US$) in Qatar in 2000 to that in 2004?
Your response must be concise. 1.86. What is the ratio of the Aid flow (current US$) of Least developed countries in 2001 to that in 2002?
Provide a short and direct response. 0.73. What is the ratio of the Aid flow (current US$) in Congo (Republic) in 2001 to that in 2002?
Make the answer very short. 0.64. What is the ratio of the Aid flow (current US$) of Pakistan in 2001 to that in 2002?
Offer a very short reply. 0.26. What is the ratio of the Aid flow (current US$) of Qatar in 2001 to that in 2002?
Offer a very short reply. 1. What is the ratio of the Aid flow (current US$) in Least developed countries in 2001 to that in 2003?
Keep it short and to the point. 0.39. What is the ratio of the Aid flow (current US$) of Congo (Republic) in 2001 to that in 2003?
Offer a terse response. 1.95. What is the ratio of the Aid flow (current US$) of Qatar in 2001 to that in 2003?
Make the answer very short. 1.14. What is the ratio of the Aid flow (current US$) in Least developed countries in 2001 to that in 2004?
Provide a succinct answer. 0.62. What is the ratio of the Aid flow (current US$) in Congo (Republic) in 2001 to that in 2004?
Ensure brevity in your answer.  3.19. What is the ratio of the Aid flow (current US$) of Qatar in 2001 to that in 2004?
Offer a terse response. 1.14. What is the ratio of the Aid flow (current US$) of Least developed countries in 2002 to that in 2003?
Offer a terse response. 0.53. What is the ratio of the Aid flow (current US$) of Congo (Republic) in 2002 to that in 2003?
Provide a succinct answer. 3.06. What is the ratio of the Aid flow (current US$) in Least developed countries in 2002 to that in 2004?
Offer a terse response. 0.85. What is the ratio of the Aid flow (current US$) of Congo (Republic) in 2002 to that in 2004?
Keep it short and to the point. 5. What is the ratio of the Aid flow (current US$) in Pakistan in 2002 to that in 2004?
Your response must be concise. 3.73. What is the ratio of the Aid flow (current US$) of Qatar in 2002 to that in 2004?
Provide a short and direct response. 1.14. What is the ratio of the Aid flow (current US$) in Least developed countries in 2003 to that in 2004?
Provide a short and direct response. 1.61. What is the ratio of the Aid flow (current US$) in Congo (Republic) in 2003 to that in 2004?
Keep it short and to the point. 1.63. What is the ratio of the Aid flow (current US$) in Qatar in 2003 to that in 2004?
Give a very brief answer. 1. What is the difference between the highest and the second highest Aid flow (current US$) in Least developed countries?
Give a very brief answer. 5.89e+08. What is the difference between the highest and the second highest Aid flow (current US$) of Congo (Republic)?
Provide a short and direct response. 5.52e+06. What is the difference between the highest and the second highest Aid flow (current US$) of Pakistan?
Make the answer very short. 7.25e+06. What is the difference between the highest and the second highest Aid flow (current US$) in Qatar?
Give a very brief answer. 10000. What is the difference between the highest and the lowest Aid flow (current US$) of Least developed countries?
Make the answer very short. 9.50e+08. What is the difference between the highest and the lowest Aid flow (current US$) of Congo (Republic)?
Your answer should be very brief. 1.30e+07. What is the difference between the highest and the lowest Aid flow (current US$) of Pakistan?
Ensure brevity in your answer.  8.34e+07. What is the difference between the highest and the lowest Aid flow (current US$) in Qatar?
Your response must be concise. 9.00e+04. 